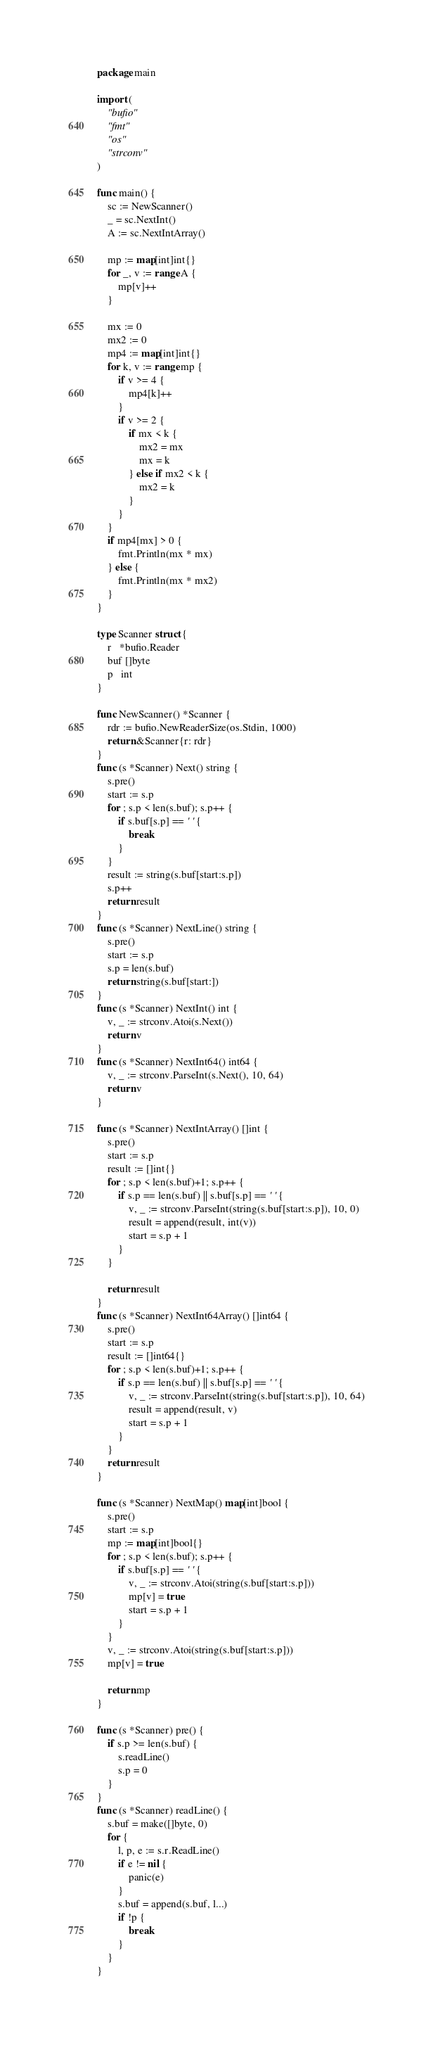<code> <loc_0><loc_0><loc_500><loc_500><_Go_>package main

import (
	"bufio"
	"fmt"
	"os"
	"strconv"
)

func main() {
	sc := NewScanner()
	_ = sc.NextInt()
	A := sc.NextIntArray()

	mp := map[int]int{}
	for _, v := range A {
		mp[v]++
	}

	mx := 0
	mx2 := 0
	mp4 := map[int]int{}
	for k, v := range mp {
		if v >= 4 {
			mp4[k]++
		}
		if v >= 2 {
			if mx < k {
				mx2 = mx
				mx = k
			} else if mx2 < k {
				mx2 = k
			}
		}
	}
	if mp4[mx] > 0 {
		fmt.Println(mx * mx)
	} else {
		fmt.Println(mx * mx2)
	}
}

type Scanner struct {
	r   *bufio.Reader
	buf []byte
	p   int
}

func NewScanner() *Scanner {
	rdr := bufio.NewReaderSize(os.Stdin, 1000)
	return &Scanner{r: rdr}
}
func (s *Scanner) Next() string {
	s.pre()
	start := s.p
	for ; s.p < len(s.buf); s.p++ {
		if s.buf[s.p] == ' ' {
			break
		}
	}
	result := string(s.buf[start:s.p])
	s.p++
	return result
}
func (s *Scanner) NextLine() string {
	s.pre()
	start := s.p
	s.p = len(s.buf)
	return string(s.buf[start:])
}
func (s *Scanner) NextInt() int {
	v, _ := strconv.Atoi(s.Next())
	return v
}
func (s *Scanner) NextInt64() int64 {
	v, _ := strconv.ParseInt(s.Next(), 10, 64)
	return v
}

func (s *Scanner) NextIntArray() []int {
	s.pre()
	start := s.p
	result := []int{}
	for ; s.p < len(s.buf)+1; s.p++ {
		if s.p == len(s.buf) || s.buf[s.p] == ' ' {
			v, _ := strconv.ParseInt(string(s.buf[start:s.p]), 10, 0)
			result = append(result, int(v))
			start = s.p + 1
		}
	}

	return result
}
func (s *Scanner) NextInt64Array() []int64 {
	s.pre()
	start := s.p
	result := []int64{}
	for ; s.p < len(s.buf)+1; s.p++ {
		if s.p == len(s.buf) || s.buf[s.p] == ' ' {
			v, _ := strconv.ParseInt(string(s.buf[start:s.p]), 10, 64)
			result = append(result, v)
			start = s.p + 1
		}
	}
	return result
}

func (s *Scanner) NextMap() map[int]bool {
	s.pre()
	start := s.p
	mp := map[int]bool{}
	for ; s.p < len(s.buf); s.p++ {
		if s.buf[s.p] == ' ' {
			v, _ := strconv.Atoi(string(s.buf[start:s.p]))
			mp[v] = true
			start = s.p + 1
		}
	}
	v, _ := strconv.Atoi(string(s.buf[start:s.p]))
	mp[v] = true

	return mp
}

func (s *Scanner) pre() {
	if s.p >= len(s.buf) {
		s.readLine()
		s.p = 0
	}
}
func (s *Scanner) readLine() {
	s.buf = make([]byte, 0)
	for {
		l, p, e := s.r.ReadLine()
		if e != nil {
			panic(e)
		}
		s.buf = append(s.buf, l...)
		if !p {
			break
		}
	}
}
</code> 